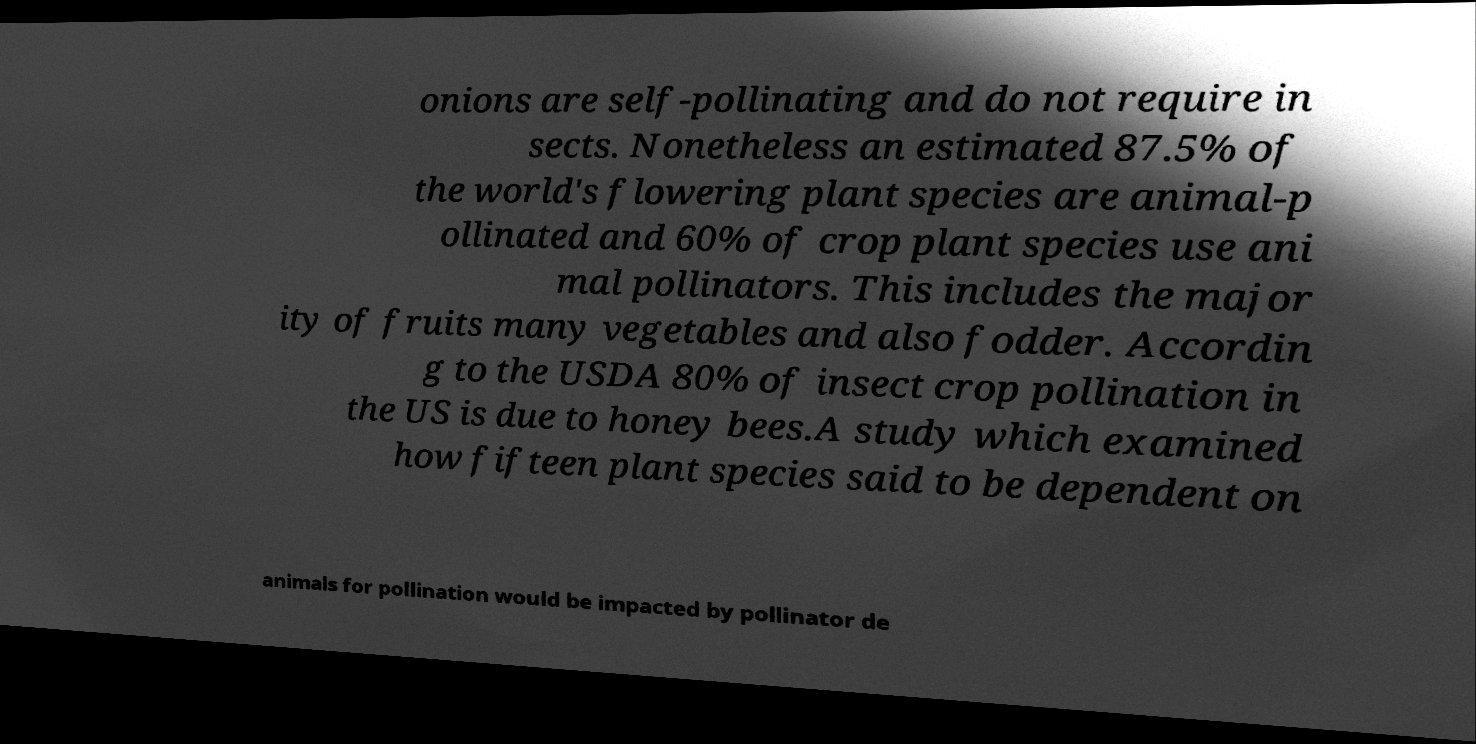Please identify and transcribe the text found in this image. onions are self-pollinating and do not require in sects. Nonetheless an estimated 87.5% of the world's flowering plant species are animal-p ollinated and 60% of crop plant species use ani mal pollinators. This includes the major ity of fruits many vegetables and also fodder. Accordin g to the USDA 80% of insect crop pollination in the US is due to honey bees.A study which examined how fifteen plant species said to be dependent on animals for pollination would be impacted by pollinator de 